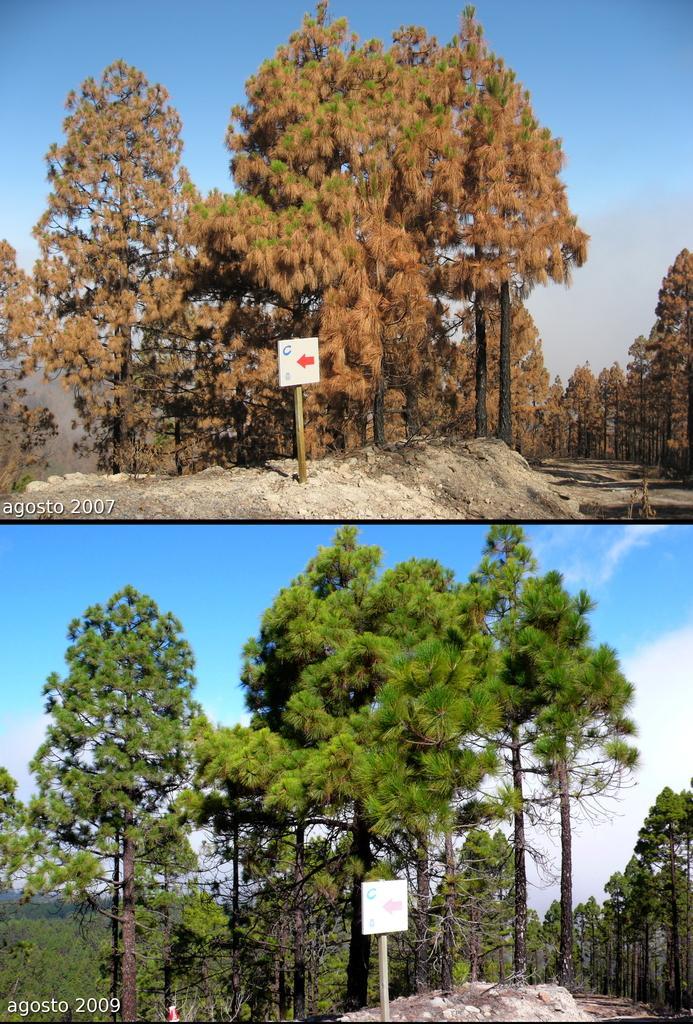In one or two sentences, can you explain what this image depicts? This is an edited image. This picture is the collage of two images. At the bottom, we see trees, a pole and a board in white color. In the background, we see the sky, which is blue in color. At the top, we see trees, a pole and a board in white color. We even see the sky, which is blue in color. 